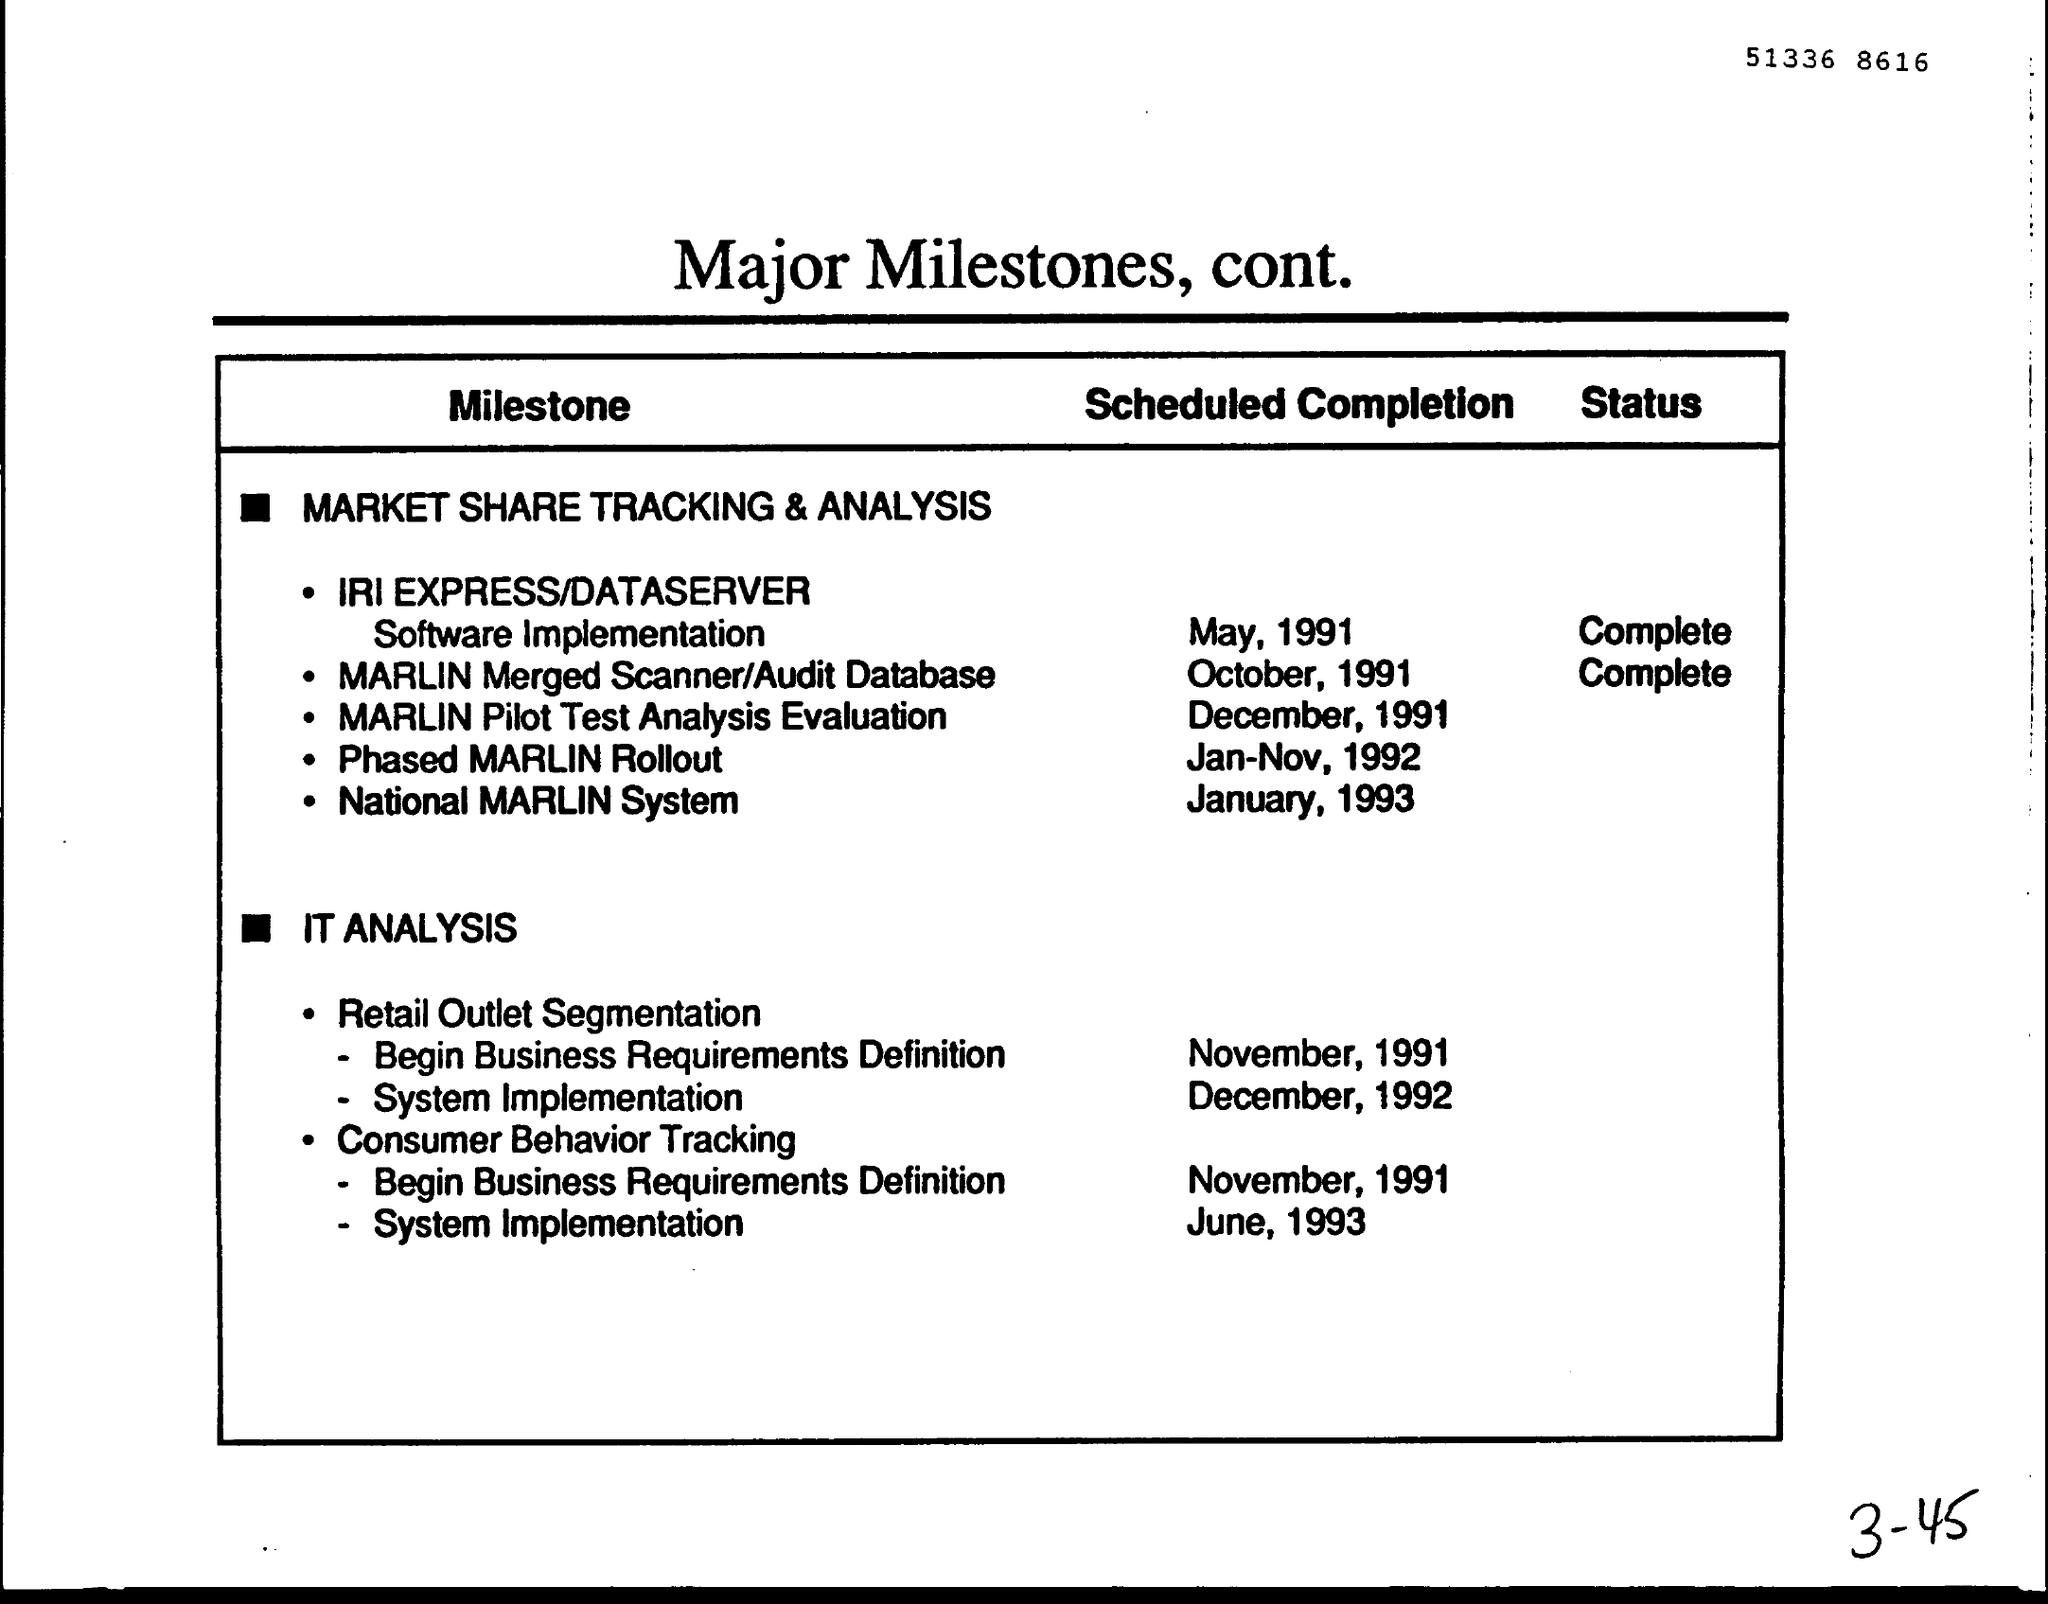What is the number written at the top of the page?
Offer a terse response. 51336 8616. When is the scheduled completion of National MARLIN System?
Make the answer very short. January, 1993. What is the status of MARLIN Merged Scanner/ Audit Database?
Ensure brevity in your answer.  Complete. When is the scheduled completion of System Implementation of Retail outlet segmentation??
Make the answer very short. December, 1992. What is the document title?
Your response must be concise. Major Milestones, cont. 